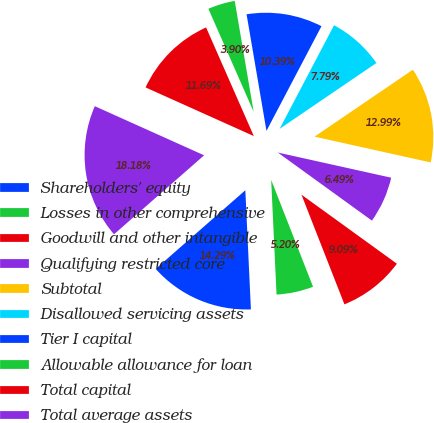<chart> <loc_0><loc_0><loc_500><loc_500><pie_chart><fcel>Shareholders' equity<fcel>Losses in other comprehensive<fcel>Goodwill and other intangible<fcel>Qualifying restricted core<fcel>Subtotal<fcel>Disallowed servicing assets<fcel>Tier I capital<fcel>Allowable allowance for loan<fcel>Total capital<fcel>Total average assets<nl><fcel>14.29%<fcel>5.2%<fcel>9.09%<fcel>6.49%<fcel>12.99%<fcel>7.79%<fcel>10.39%<fcel>3.9%<fcel>11.69%<fcel>18.18%<nl></chart> 